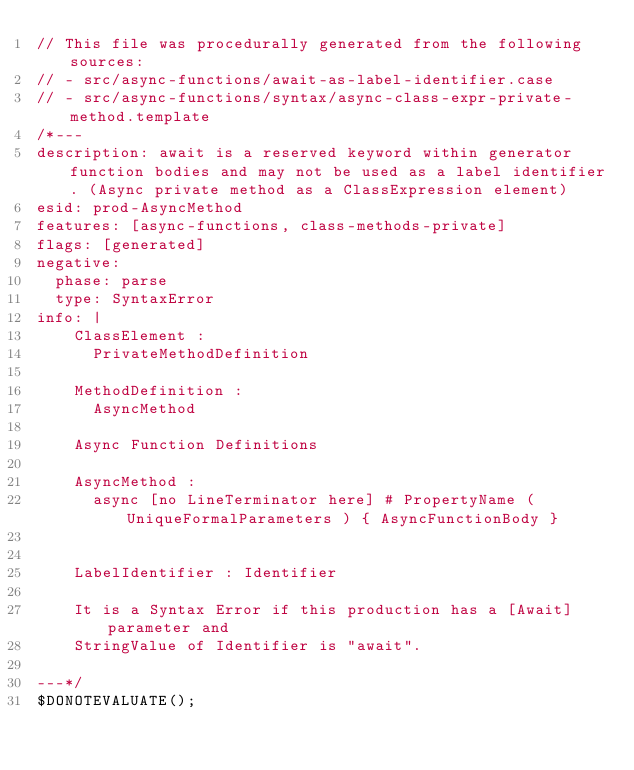<code> <loc_0><loc_0><loc_500><loc_500><_JavaScript_>// This file was procedurally generated from the following sources:
// - src/async-functions/await-as-label-identifier.case
// - src/async-functions/syntax/async-class-expr-private-method.template
/*---
description: await is a reserved keyword within generator function bodies and may not be used as a label identifier. (Async private method as a ClassExpression element)
esid: prod-AsyncMethod
features: [async-functions, class-methods-private]
flags: [generated]
negative:
  phase: parse
  type: SyntaxError
info: |
    ClassElement :
      PrivateMethodDefinition

    MethodDefinition :
      AsyncMethod

    Async Function Definitions

    AsyncMethod :
      async [no LineTerminator here] # PropertyName ( UniqueFormalParameters ) { AsyncFunctionBody }


    LabelIdentifier : Identifier

    It is a Syntax Error if this production has a [Await] parameter and
    StringValue of Identifier is "await".

---*/
$DONOTEVALUATE();

</code> 